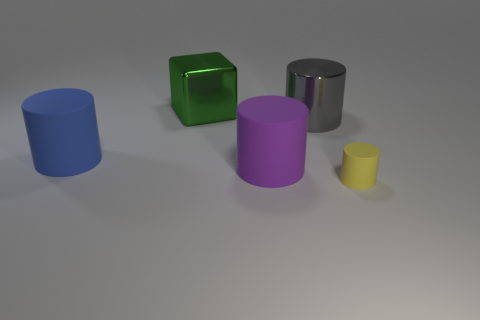Subtract all blue matte cylinders. How many cylinders are left? 3 Add 4 big green shiny cubes. How many objects exist? 9 Subtract all purple cylinders. How many cylinders are left? 3 Subtract 2 cylinders. How many cylinders are left? 2 Subtract 1 yellow cylinders. How many objects are left? 4 Subtract all cylinders. How many objects are left? 1 Subtract all cyan cylinders. Subtract all purple cubes. How many cylinders are left? 4 Subtract all green rubber spheres. Subtract all green metal things. How many objects are left? 4 Add 2 big purple cylinders. How many big purple cylinders are left? 3 Add 5 tiny gray shiny objects. How many tiny gray shiny objects exist? 5 